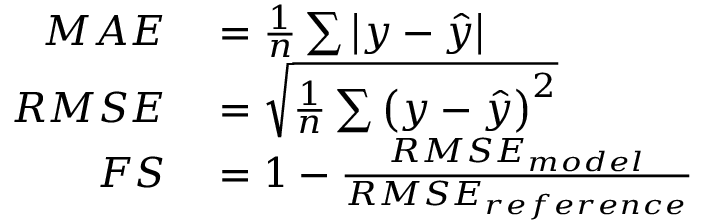<formula> <loc_0><loc_0><loc_500><loc_500>\begin{array} { r l } { M A E } & = \frac { 1 } { n } \sum \left | y - \hat { y } \right | } \\ { R M S E } & = \sqrt { \frac { 1 } { n } \sum \left ( y - \hat { y } \right ) ^ { 2 } } } \\ { F S } & = 1 - \frac { R M S E _ { m o d e l } } { R M S E _ { r e f e r e n c e } } } \end{array}</formula> 